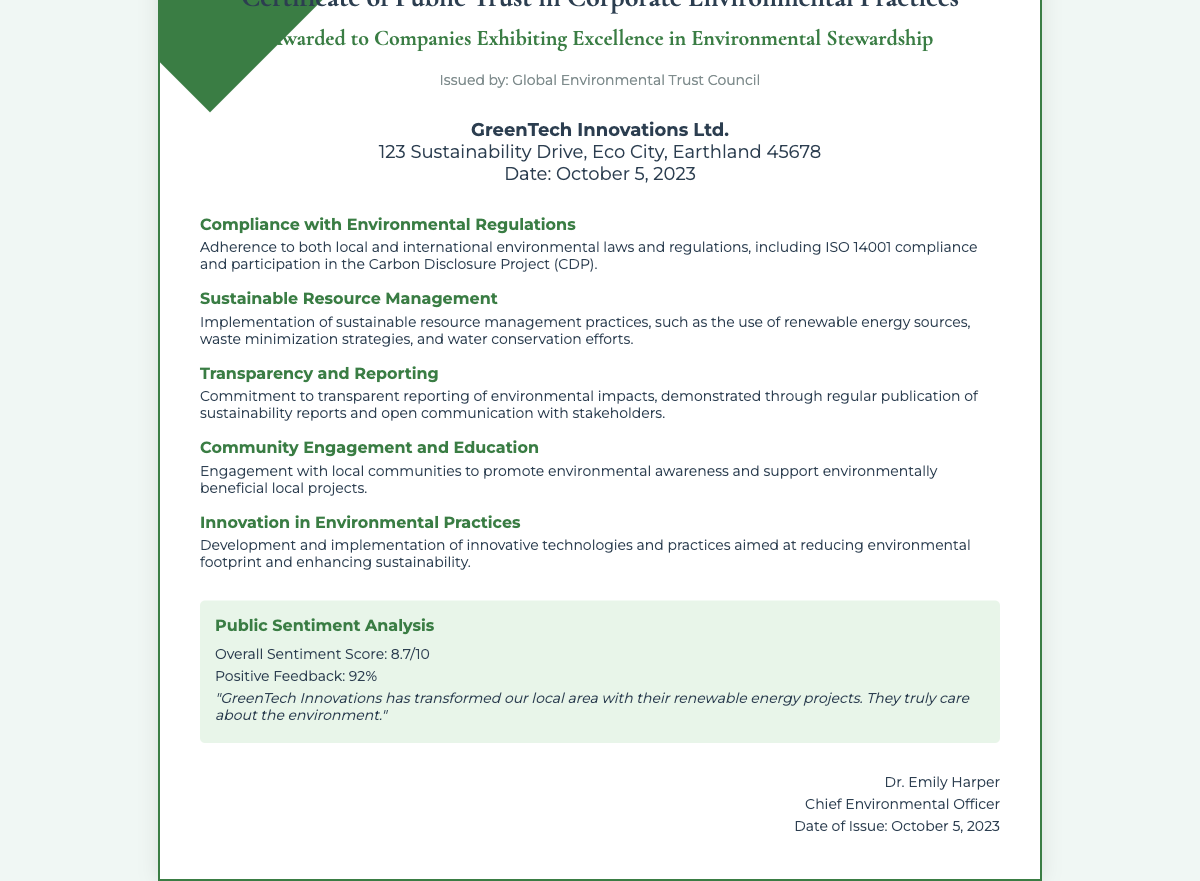What is the name of the awarded company? The document states that the certificate is awarded to "GreenTech Innovations Ltd."
Answer: GreenTech Innovations Ltd What is the issuing organization? The issuer of the certificate is identified as "Global Environmental Trust Council."
Answer: Global Environmental Trust Council What date was the certificate issued? The date of issue mentioned in the document is "October 5, 2023."
Answer: October 5, 2023 What is the overall sentiment score? The sentiment score provided in the document is "8.7/10."
Answer: 8.7/10 How much positive feedback percentage is reported? The document indicates the positive feedback to be "92%."
Answer: 92% What is one criterion related to transparency? One of the criteria related to transparency is "Commitment to transparent reporting of environmental impacts."
Answer: Commitment to transparent reporting of environmental impacts What kind of engagement is emphasized in the certificate? The certificate highlights "Community Engagement and Education."
Answer: Community Engagement and Education Name one aspect of sustainable resource management mentioned. The document lists "the use of renewable energy sources" as an aspect of sustainable resource management.
Answer: the use of renewable energy sources Who signed the certificate? The document states that the certificate was signed by "Dr. Emily Harper."
Answer: Dr. Emily Harper 